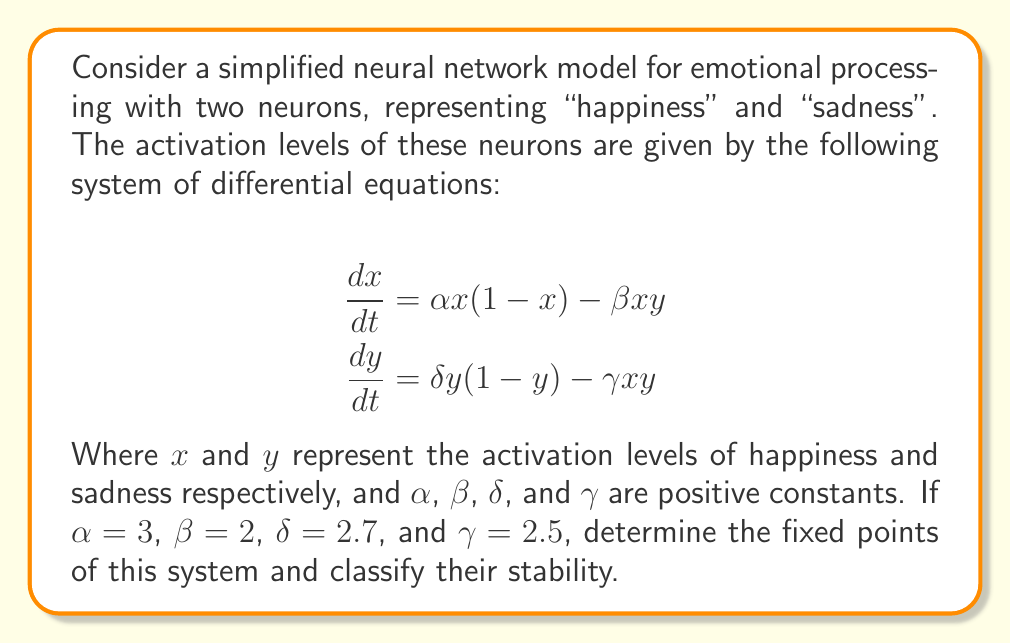Solve this math problem. To solve this problem, we'll follow these steps:

1) Find the fixed points by setting $\frac{dx}{dt} = 0$ and $\frac{dy}{dt} = 0$:

   $$\begin{align}
   0 &= 3x(1-x) - 2xy \\
   0 &= 2.7y(1-y) - 2.5xy
   \end{align}$$

2) Solve these equations:
   
   From the first equation:
   $$3x - 3x^2 - 2xy = 0$$
   $$x(3 - 3x - 2y) = 0$$
   
   So, either $x = 0$ or $3 - 3x - 2y = 0$

   From the second equation:
   $$2.7y - 2.7y^2 - 2.5xy = 0$$
   $$y(2.7 - 2.7y - 2.5x) = 0$$
   
   So, either $y = 0$ or $2.7 - 2.7y - 2.5x = 0$

3) Combine these results:

   - $(0, 0)$ is clearly a fixed point
   - If $x = 0$ and $y \neq 0$, then $y = 1$ from the second equation
   - If $y = 0$ and $x \neq 0$, then $x = 1$ from the first equation
   - If both $x \neq 0$ and $y \neq 0$, we can solve:
     
     $$\begin{align}
     3 - 3x - 2y &= 0 \\
     2.7 - 2.7y - 2.5x &= 0
     \end{align}$$
     
     Solving this system gives $x = \frac{9}{11}$ and $y = \frac{6}{11}$

4) To classify stability, we need to find the Jacobian matrix:

   $$J = \begin{bmatrix}
   3 - 6x - 2y & -2x \\
   -2.5y & 2.7 - 5.4y - 2.5x
   \end{bmatrix}$$

5) Evaluate the Jacobian at each fixed point and find eigenvalues:

   - At $(0, 0)$: 
     $$J = \begin{bmatrix}
     3 & 0 \\
     0 & 2.7
     \end{bmatrix}$$
     Eigenvalues: 3 and 2.7 (both positive, unstable node)

   - At $(1, 0)$:
     $$J = \begin{bmatrix}
     -3 & -2 \\
     0 & 0.2
     \end{bmatrix}$$
     Eigenvalues: -3 and 0.2 (saddle point)

   - At $(0, 1)$:
     $$J = \begin{bmatrix}
     1 & 0 \\
     -2.5 & -2.7
     \end{bmatrix}$$
     Eigenvalues: 1 and -2.7 (saddle point)

   - At $(\frac{9}{11}, \frac{6}{11})$:
     $$J = \begin{bmatrix}
     -\frac{9}{11} & -\frac{18}{11} \\
     -\frac{15}{11} & -\frac{9}{11}
     \end{bmatrix}$$
     Eigenvalues: $-0.818 \pm 1.386i$ (stable spiral)
Answer: Fixed points: $(0,0)$, $(1,0)$, $(0,1)$, $(\frac{9}{11},\frac{6}{11})$. Stability: unstable node, saddle point, saddle point, stable spiral, respectively. 